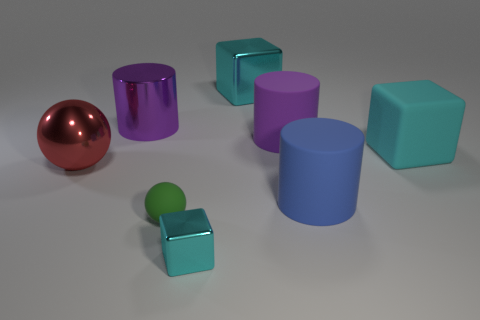Subtract all blue cubes. How many purple cylinders are left? 2 Subtract all big cyan shiny cubes. How many cubes are left? 2 Subtract 1 blocks. How many blocks are left? 2 Subtract all red cylinders. Subtract all red balls. How many cylinders are left? 3 Add 1 tiny purple metal cubes. How many objects exist? 9 Subtract all cylinders. How many objects are left? 5 Subtract all shiny blocks. Subtract all red spheres. How many objects are left? 5 Add 5 large cyan matte things. How many large cyan matte things are left? 6 Add 4 red metallic objects. How many red metallic objects exist? 5 Subtract 0 red cylinders. How many objects are left? 8 